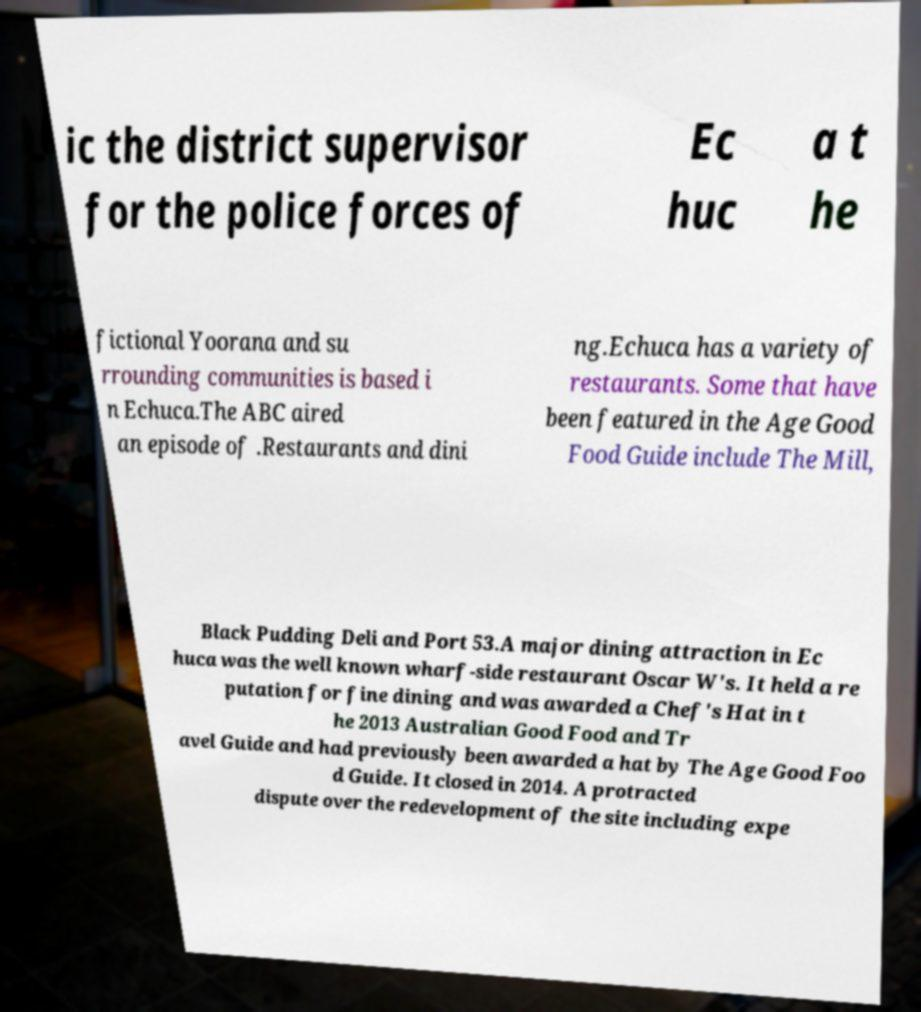Please read and relay the text visible in this image. What does it say? ic the district supervisor for the police forces of Ec huc a t he fictional Yoorana and su rrounding communities is based i n Echuca.The ABC aired an episode of .Restaurants and dini ng.Echuca has a variety of restaurants. Some that have been featured in the Age Good Food Guide include The Mill, Black Pudding Deli and Port 53.A major dining attraction in Ec huca was the well known wharf-side restaurant Oscar W's. It held a re putation for fine dining and was awarded a Chef's Hat in t he 2013 Australian Good Food and Tr avel Guide and had previously been awarded a hat by The Age Good Foo d Guide. It closed in 2014. A protracted dispute over the redevelopment of the site including expe 